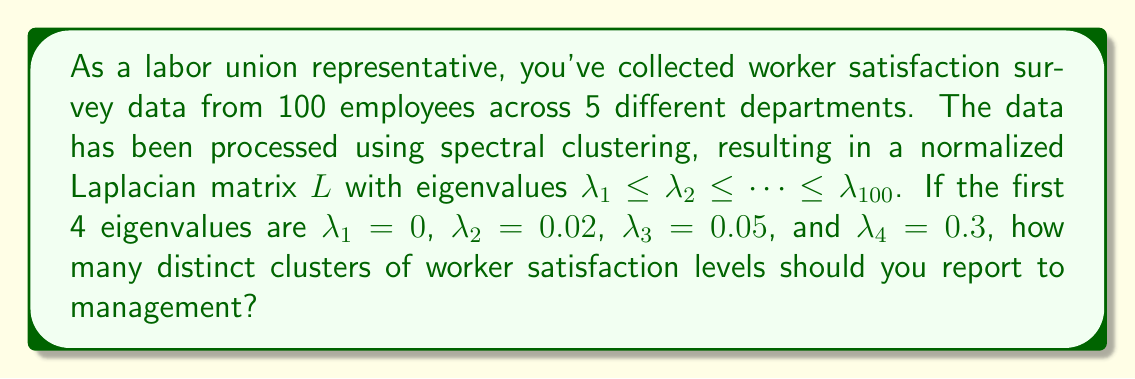Solve this math problem. To determine the number of distinct clusters in spectral clustering, we use the eigengap heuristic. This method involves finding the largest gap between consecutive eigenvalues of the normalized Laplacian matrix.

Step 1: List the given eigenvalues in ascending order:
$\lambda_1 = 0$, $\lambda_2 = 0.02$, $\lambda_3 = 0.05$, $\lambda_4 = 0.3$

Step 2: Calculate the gaps between consecutive eigenvalues:
Gap 1-2: $0.02 - 0 = 0.02$
Gap 2-3: $0.05 - 0.02 = 0.03$
Gap 3-4: $0.3 - 0.05 = 0.25$

Step 3: Identify the largest gap:
The largest gap is between $\lambda_3$ and $\lambda_4$, with a value of 0.25.

Step 4: Determine the number of clusters:
The number of clusters is equal to the index of the eigenvalue before the largest gap. In this case, it's the index of $\lambda_3$, which is 3.

Therefore, you should report 3 distinct clusters of worker satisfaction levels to management.
Answer: 3 clusters 